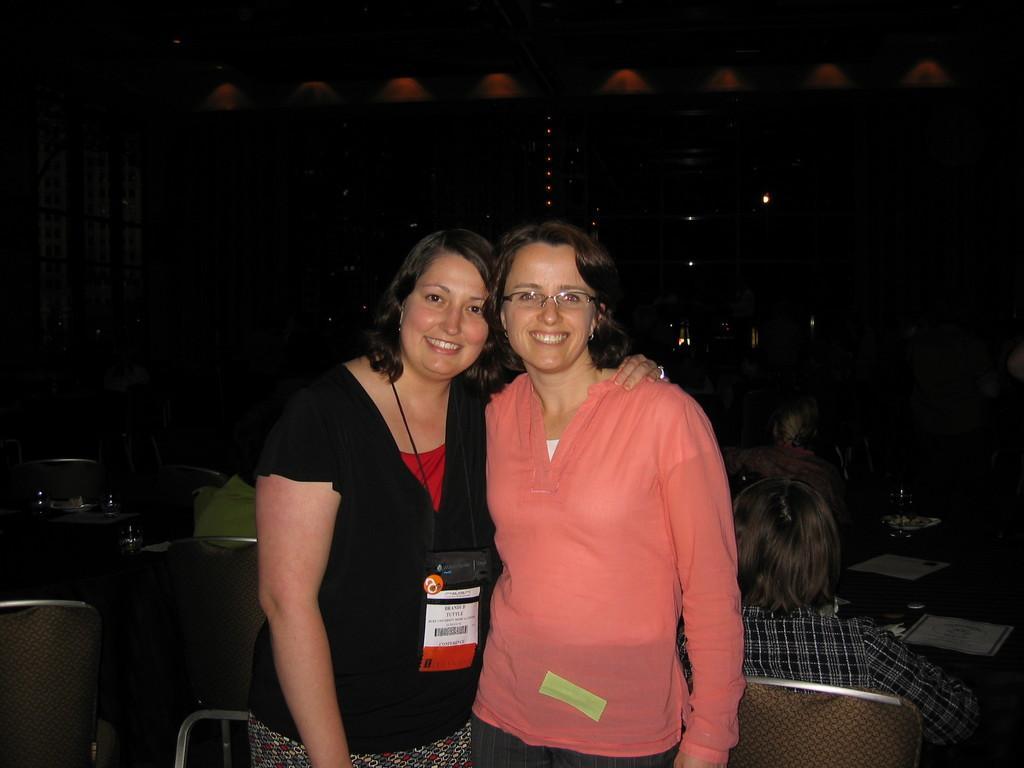Please provide a concise description of this image. This picture shows a couple of women standing with smile on their faces and we see woman wore a id card and another woman wore spectacles on her face and we see few people seated on the chairs and we see glasses and papers on the tables and the background is black in color. 